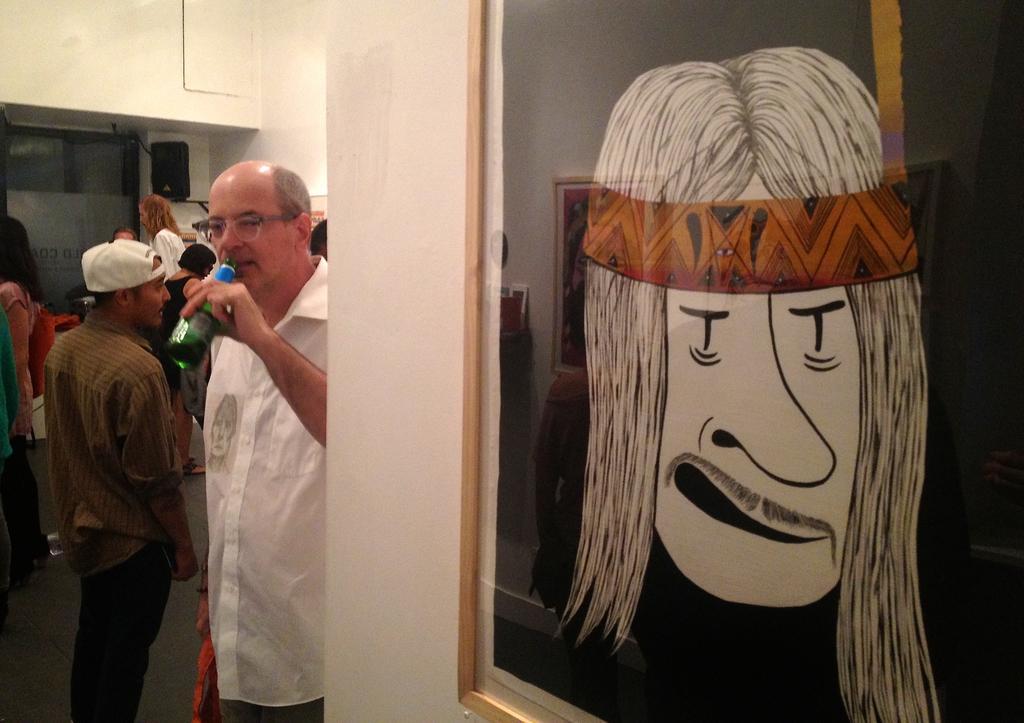Could you give a brief overview of what you see in this image? On the right side, there is a photo frame having a painting, attached to a white wall. On the left side, there is a person in white color shirt, holding a bottle and standing. Beside him, there is another person. In the background, there are other persons, there is a speaker and there is a white wall. 